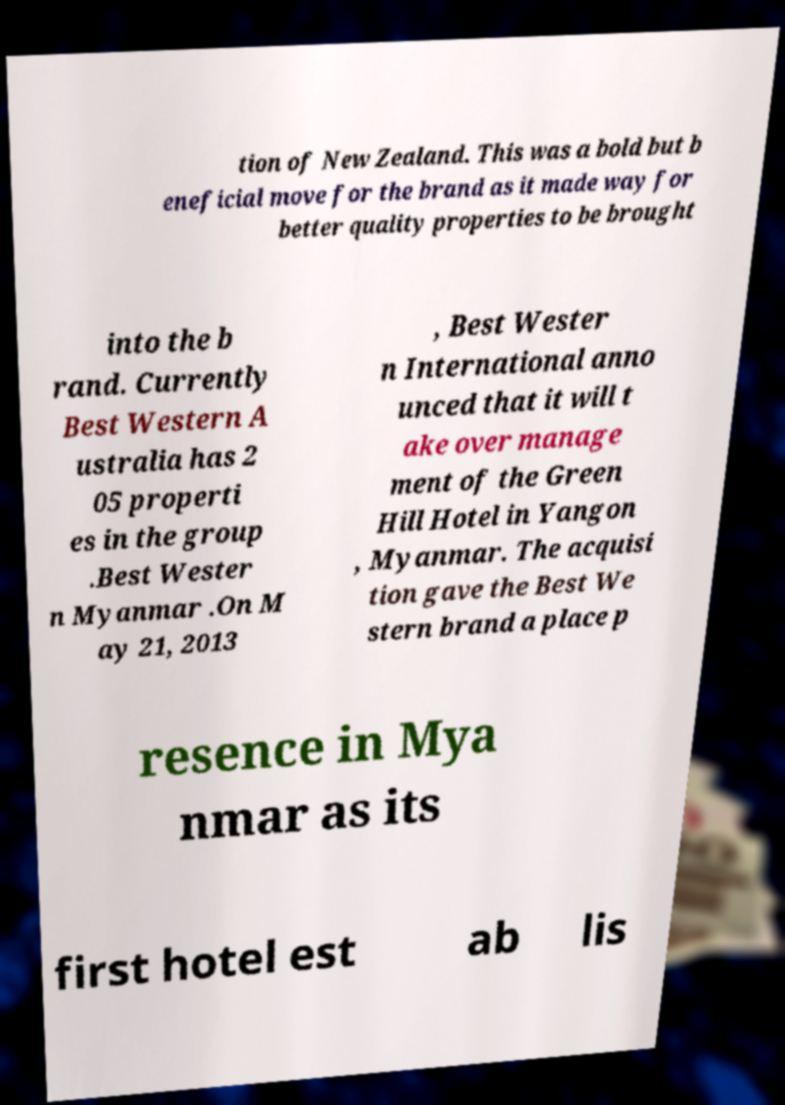For documentation purposes, I need the text within this image transcribed. Could you provide that? tion of New Zealand. This was a bold but b eneficial move for the brand as it made way for better quality properties to be brought into the b rand. Currently Best Western A ustralia has 2 05 properti es in the group .Best Wester n Myanmar .On M ay 21, 2013 , Best Wester n International anno unced that it will t ake over manage ment of the Green Hill Hotel in Yangon , Myanmar. The acquisi tion gave the Best We stern brand a place p resence in Mya nmar as its first hotel est ab lis 